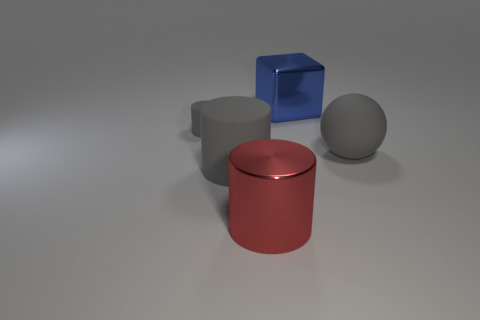Are there more large gray matte things in front of the large gray ball than tiny blue balls?
Offer a very short reply. Yes. Does the big sphere have the same color as the big rubber cylinder?
Give a very brief answer. Yes. How many other big red things have the same shape as the large red metallic object?
Ensure brevity in your answer.  0. There is a cylinder that is made of the same material as the small gray object; what size is it?
Make the answer very short. Large. The object that is in front of the tiny gray cylinder and on the left side of the big red thing is what color?
Your response must be concise. Gray. How many gray cylinders have the same size as the metallic block?
Provide a succinct answer. 1. The other cylinder that is the same color as the large matte cylinder is what size?
Your answer should be compact. Small. There is a object that is both in front of the matte ball and on the right side of the big gray matte cylinder; what is its size?
Your answer should be very brief. Large. What number of big cylinders are in front of the matte thing right of the gray object that is in front of the rubber ball?
Your answer should be very brief. 2. Is there a big object that has the same color as the large sphere?
Provide a succinct answer. Yes. 